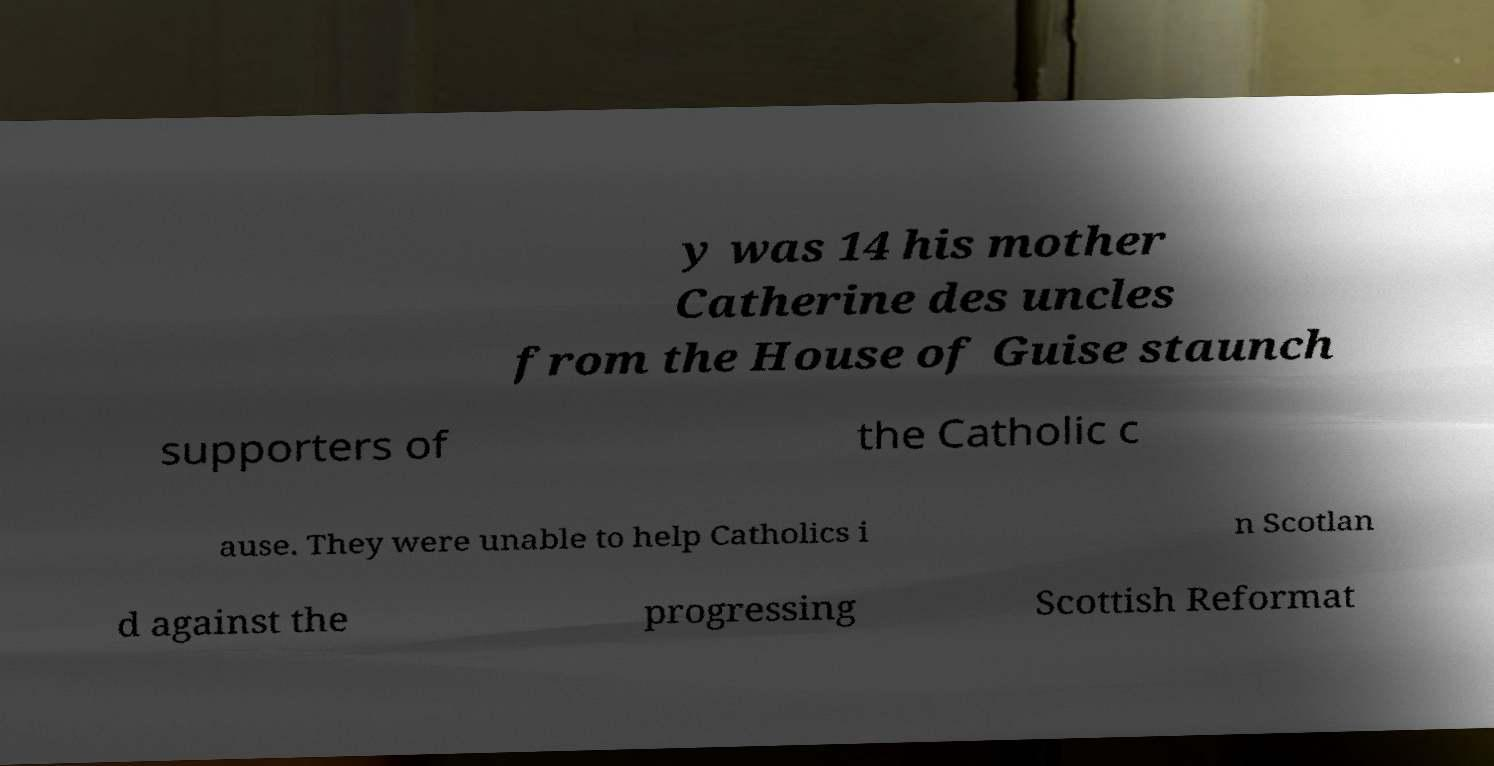Could you assist in decoding the text presented in this image and type it out clearly? y was 14 his mother Catherine des uncles from the House of Guise staunch supporters of the Catholic c ause. They were unable to help Catholics i n Scotlan d against the progressing Scottish Reformat 